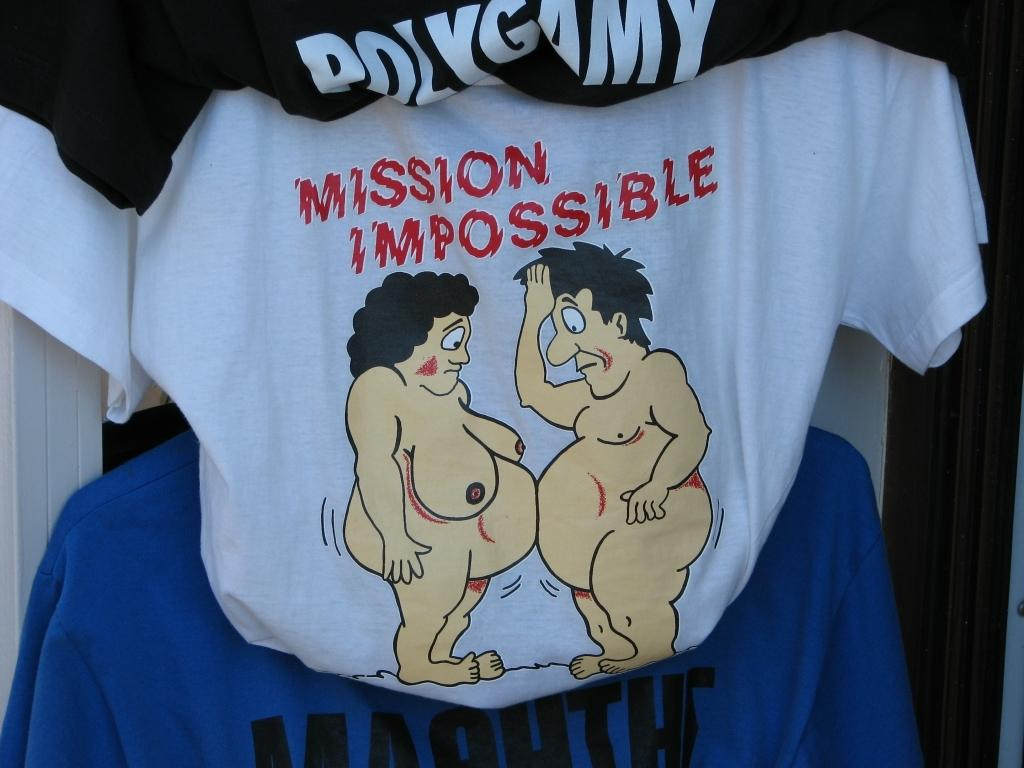Provide a one-sentence caption for the provided image. Shirt that have two naked cartoon people for mission impossible. 